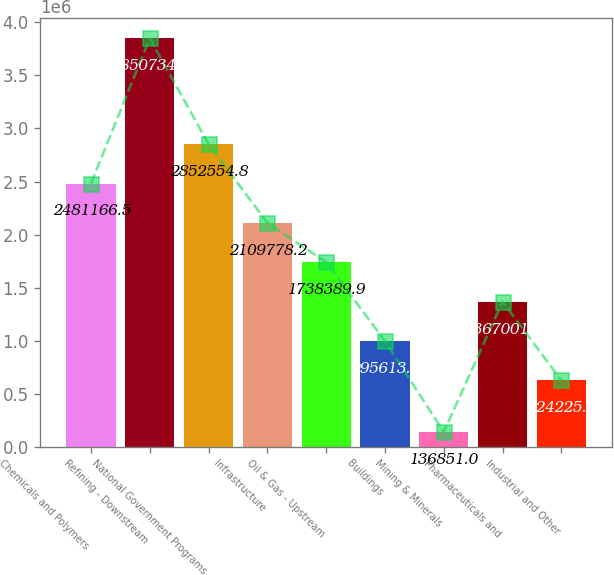Convert chart. <chart><loc_0><loc_0><loc_500><loc_500><bar_chart><fcel>Chemicals and Polymers<fcel>Refining - Downstream<fcel>National Government Programs<fcel>Infrastructure<fcel>Oil & Gas - Upstream<fcel>Buildings<fcel>Mining & Minerals<fcel>Pharmaceuticals and<fcel>Industrial and Other<nl><fcel>2.48117e+06<fcel>3.85073e+06<fcel>2.85255e+06<fcel>2.10978e+06<fcel>1.73839e+06<fcel>995613<fcel>136851<fcel>1.367e+06<fcel>624225<nl></chart> 